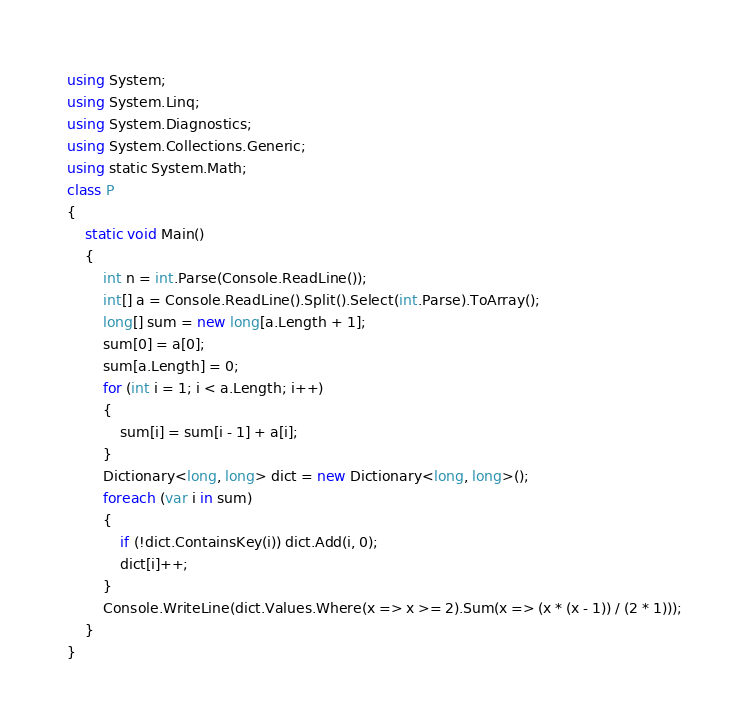Convert code to text. <code><loc_0><loc_0><loc_500><loc_500><_C#_>using System;
using System.Linq;
using System.Diagnostics;
using System.Collections.Generic;
using static System.Math;
class P
{
    static void Main()
    {
        int n = int.Parse(Console.ReadLine());
        int[] a = Console.ReadLine().Split().Select(int.Parse).ToArray();
        long[] sum = new long[a.Length + 1];
        sum[0] = a[0];
        sum[a.Length] = 0;
        for (int i = 1; i < a.Length; i++)
        {
            sum[i] = sum[i - 1] + a[i];
        }
        Dictionary<long, long> dict = new Dictionary<long, long>();
        foreach (var i in sum)
        {
            if (!dict.ContainsKey(i)) dict.Add(i, 0);
            dict[i]++;
        }
        Console.WriteLine(dict.Values.Where(x => x >= 2).Sum(x => (x * (x - 1)) / (2 * 1)));
    }
}</code> 